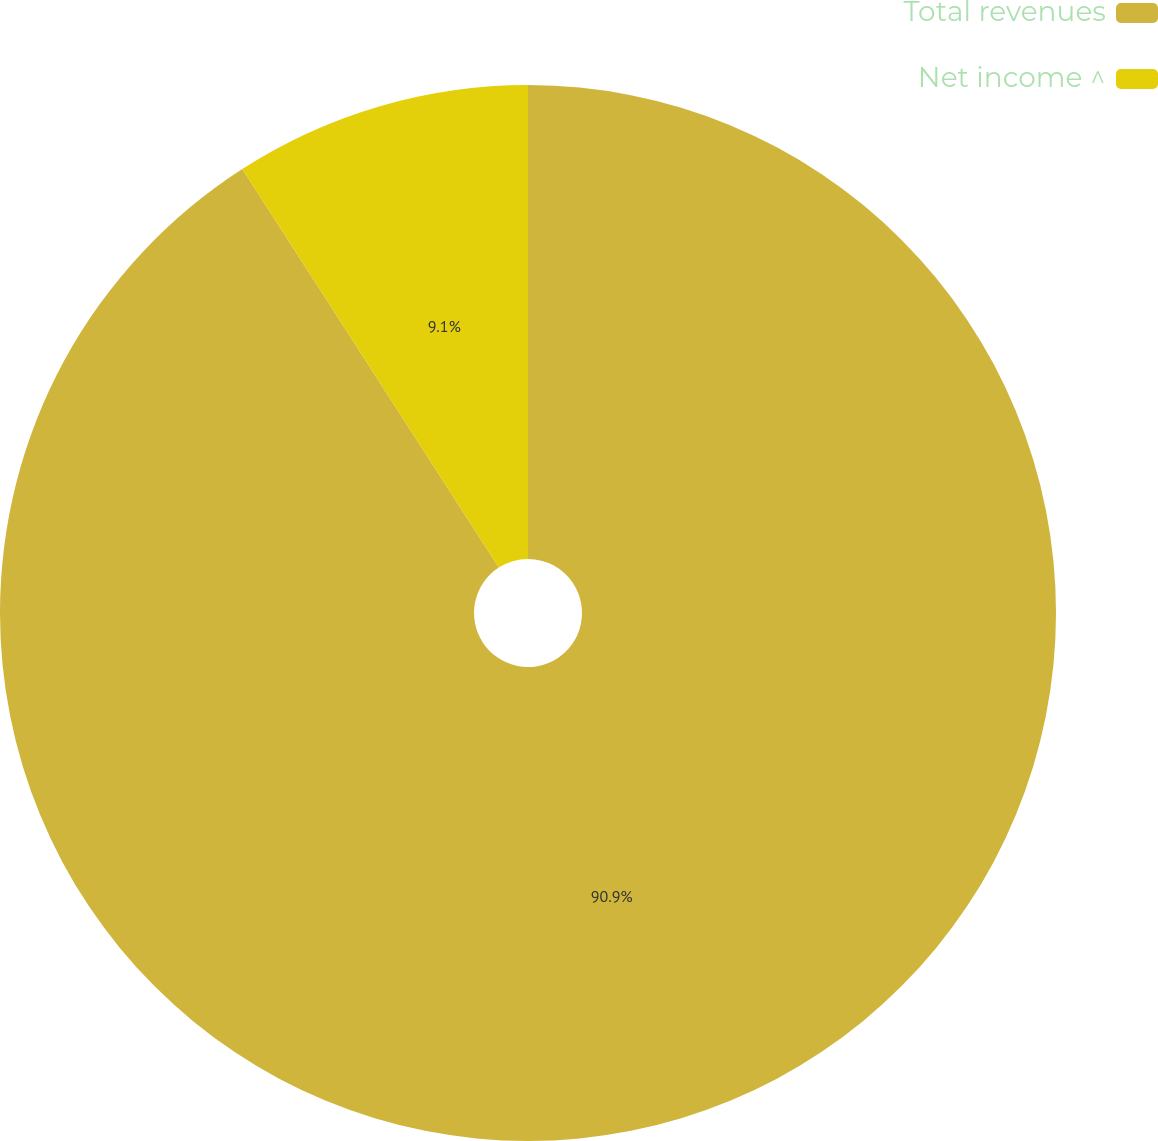Convert chart to OTSL. <chart><loc_0><loc_0><loc_500><loc_500><pie_chart><fcel>Total revenues<fcel>Net income ^<nl><fcel>90.9%<fcel>9.1%<nl></chart> 